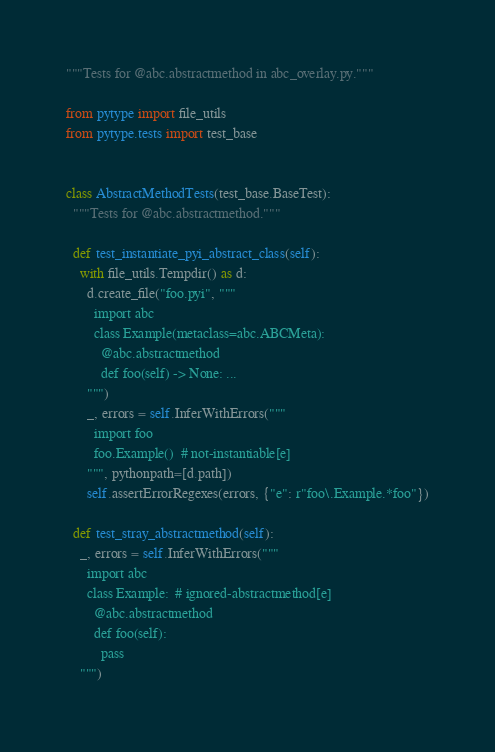<code> <loc_0><loc_0><loc_500><loc_500><_Python_>"""Tests for @abc.abstractmethod in abc_overlay.py."""

from pytype import file_utils
from pytype.tests import test_base


class AbstractMethodTests(test_base.BaseTest):
  """Tests for @abc.abstractmethod."""

  def test_instantiate_pyi_abstract_class(self):
    with file_utils.Tempdir() as d:
      d.create_file("foo.pyi", """
        import abc
        class Example(metaclass=abc.ABCMeta):
          @abc.abstractmethod
          def foo(self) -> None: ...
      """)
      _, errors = self.InferWithErrors("""
        import foo
        foo.Example()  # not-instantiable[e]
      """, pythonpath=[d.path])
      self.assertErrorRegexes(errors, {"e": r"foo\.Example.*foo"})

  def test_stray_abstractmethod(self):
    _, errors = self.InferWithErrors("""
      import abc
      class Example:  # ignored-abstractmethod[e]
        @abc.abstractmethod
        def foo(self):
          pass
    """)</code> 